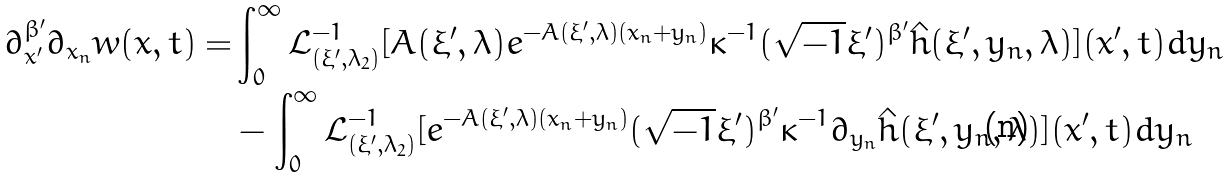<formula> <loc_0><loc_0><loc_500><loc_500>\partial ^ { \beta ^ { \prime } } _ { x ^ { \prime } } \partial _ { x _ { n } } w ( x , t ) = & \int ^ { \infty } _ { 0 } \mathcal { L } ^ { - 1 } _ { ( \xi ^ { \prime } , \lambda _ { 2 } ) } [ A ( \xi ^ { \prime } , \lambda ) e ^ { - A ( \xi ^ { \prime } , \lambda ) ( x _ { n } + y _ { n } ) } \kappa ^ { - 1 } ( \sqrt { - 1 } \xi ^ { \prime } ) ^ { \beta ^ { \prime } } \hat { h } ( \xi ^ { \prime } , y _ { n } , \lambda ) ] ( x ^ { \prime } , t ) d y _ { n } \\ & - \int ^ { \infty } _ { 0 } \mathcal { L } ^ { - 1 } _ { ( \xi ^ { \prime } , \lambda _ { 2 } ) } [ e ^ { - A ( \xi ^ { \prime } , \lambda ) ( x _ { n } + y _ { n } ) } ( \sqrt { - 1 } \xi ^ { \prime } ) ^ { \beta ^ { \prime } } \kappa ^ { - 1 } \partial _ { y _ { n } } \hat { h } ( \xi ^ { \prime } , y _ { n } , \lambda ) ] ( x ^ { \prime } , t ) d y _ { n }</formula> 